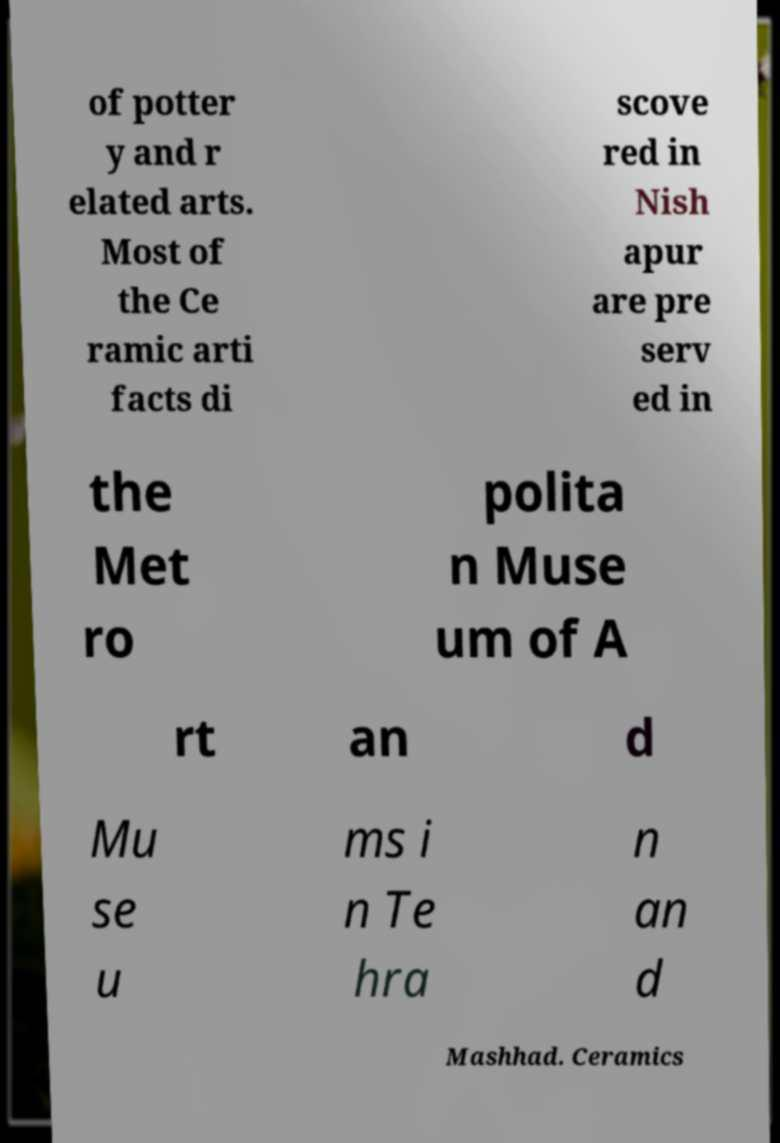Please identify and transcribe the text found in this image. of potter y and r elated arts. Most of the Ce ramic arti facts di scove red in Nish apur are pre serv ed in the Met ro polita n Muse um of A rt an d Mu se u ms i n Te hra n an d Mashhad. Ceramics 